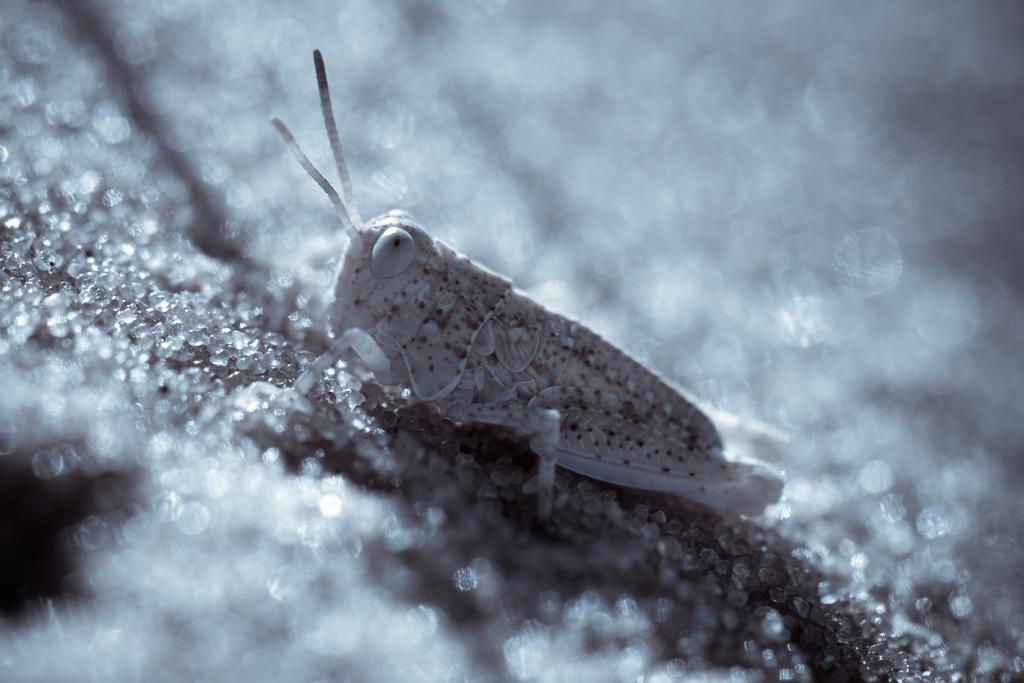What is the main subject in the center of the image? There is an insect in the center of the image. What is present at the bottom of the image? There is sugar at the bottom of the image. What type of design can be seen on the wine bottle in the image? There is no wine bottle present in the image; it only features an insect and sugar. 